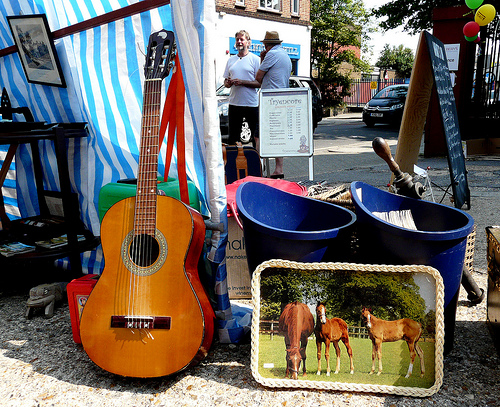<image>
Is there a man on the man? No. The man is not positioned on the man. They may be near each other, but the man is not supported by or resting on top of the man. Is the car behind the men? Yes. From this viewpoint, the car is positioned behind the men, with the men partially or fully occluding the car. Is there a frame in the barrel? No. The frame is not contained within the barrel. These objects have a different spatial relationship. 